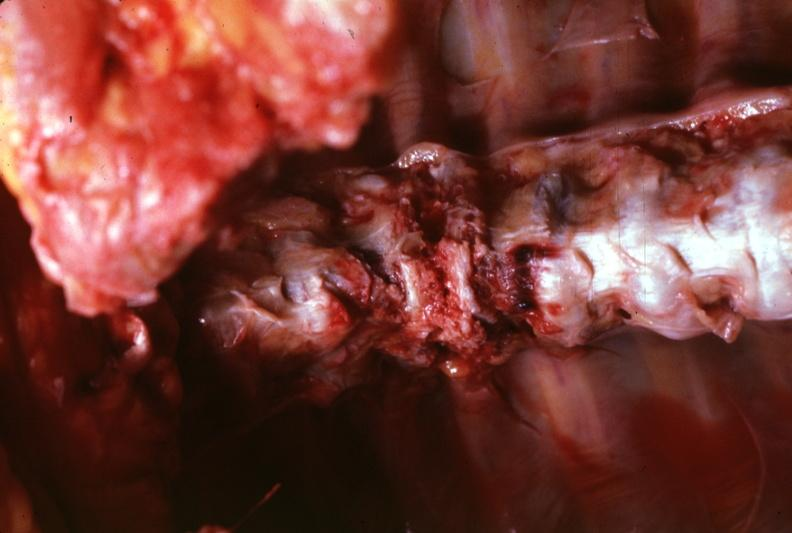s joints present?
Answer the question using a single word or phrase. Yes 